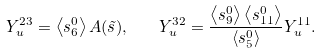Convert formula to latex. <formula><loc_0><loc_0><loc_500><loc_500>Y _ { u } ^ { 2 3 } = \left < s _ { 6 } ^ { 0 } \right > A ( \tilde { s } ) , \quad Y _ { u } ^ { 3 2 } = \frac { \left < s _ { 9 } ^ { 0 } \right > \left < s _ { 1 1 } ^ { 0 } \right > } { \left < s _ { 5 } ^ { 0 } \right > } Y _ { u } ^ { 1 1 } .</formula> 